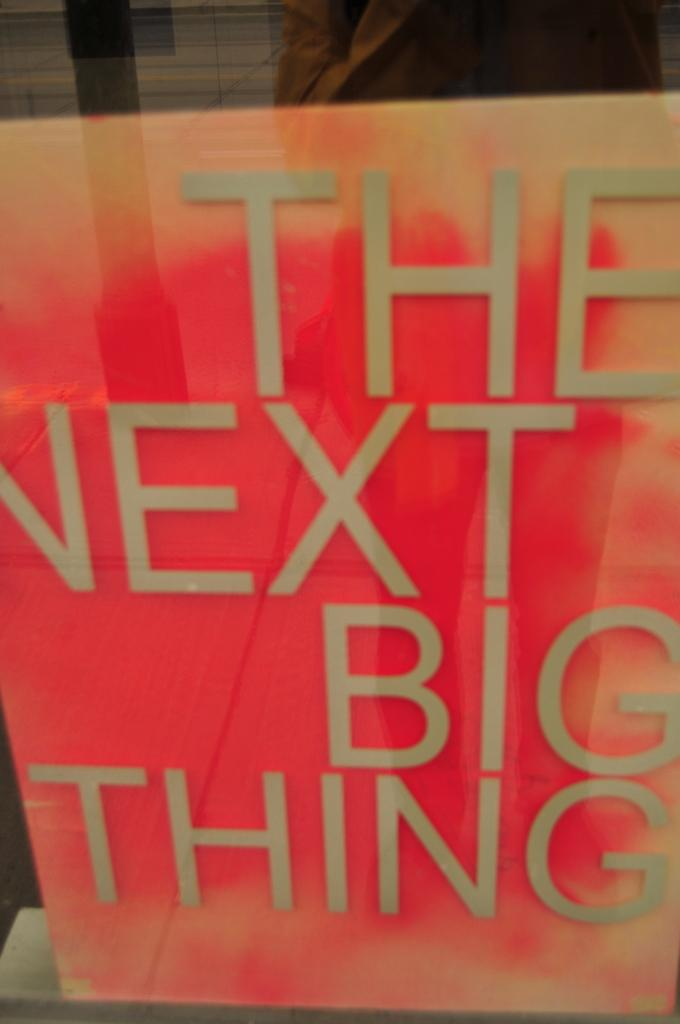<image>
Write a terse but informative summary of the picture. An ad inside a window that says The Next Big Thing. 